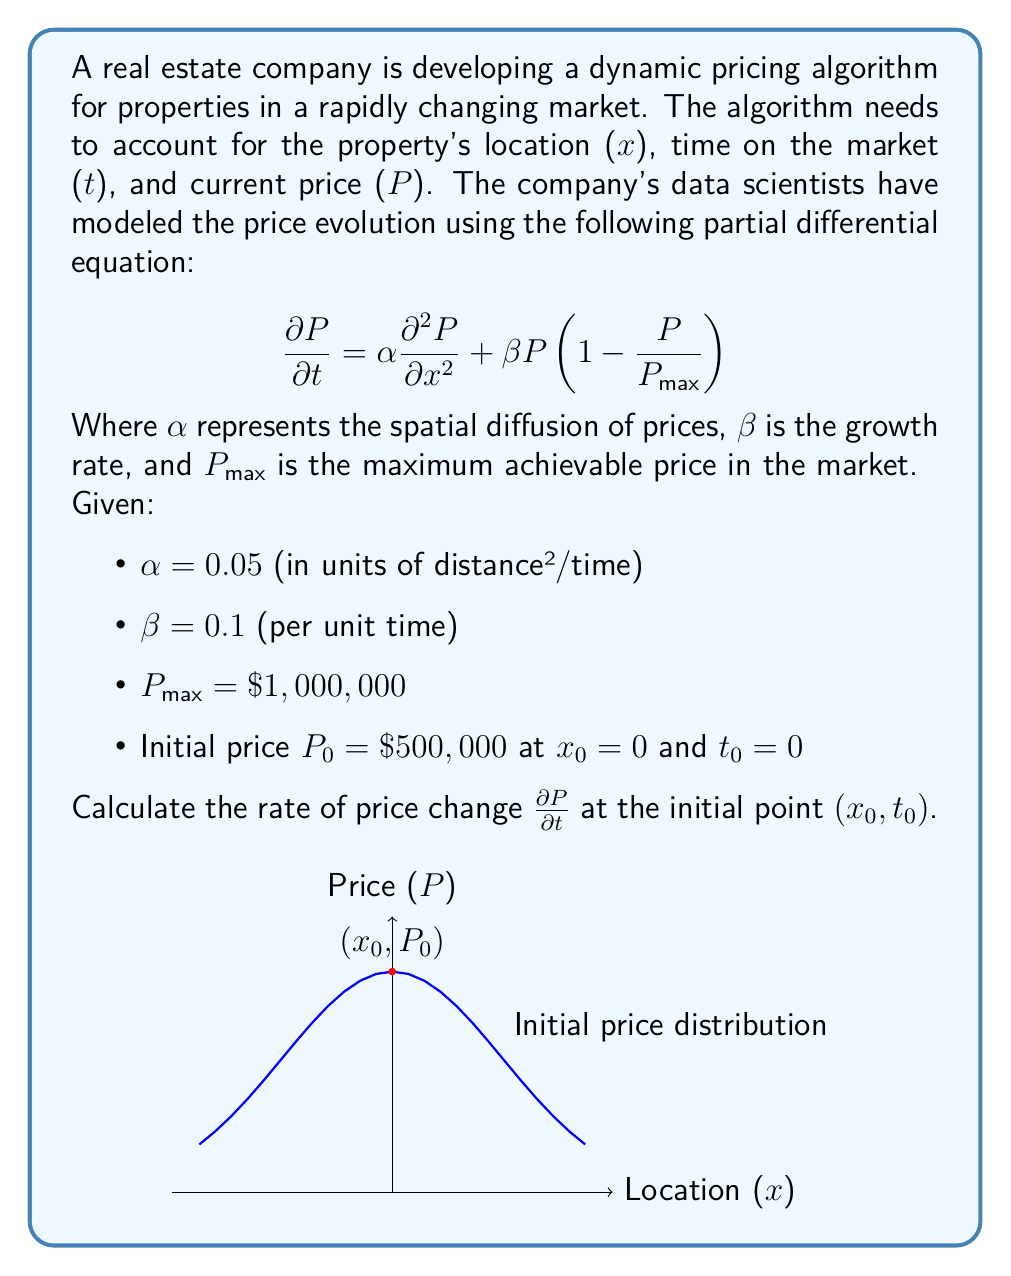Provide a solution to this math problem. To solve this problem, we need to use the given partial differential equation and substitute the known values. Let's break it down step-by-step:

1) The PDE is given as:
   $$\frac{\partial P}{\partial t} = \alpha \frac{\partial^2 P}{\partial x^2} + \beta P(1-\frac{P}{P_{max}})$$

2) We are given the following values:
   - $\alpha = 0.05$
   - $\beta = 0.1$
   - $P_{max} = \$1,000,000$
   - $P_0 = \$500,000$ at $x_0 = 0$ and $t_0 = 0$

3) At the initial point, we need to calculate $\frac{\partial P}{\partial t}$. For this, we need to know $\frac{\partial^2 P}{\partial x^2}$ and $P$.

4) We know $P = P_0 = \$500,000$ at the initial point.

5) To find $\frac{\partial^2 P}{\partial x^2}$ at $x_0 = 0$, we need additional information about the initial price distribution. Since this is not provided, we can assume it's zero at the initial point (assuming a locally flat price distribution).

6) Now, let's substitute these values into the PDE:

   $$\frac{\partial P}{\partial t} = 0.05 \cdot 0 + 0.1 \cdot 500,000(1-\frac{500,000}{1,000,000})$$

7) Simplify:
   $$\frac{\partial P}{\partial t} = 0 + 0.1 \cdot 500,000 \cdot 0.5$$
   $$\frac{\partial P}{\partial t} = 25,000$$

Therefore, at the initial point, the rate of price change is $25,000 per unit time.
Answer: $25,000 per unit time 